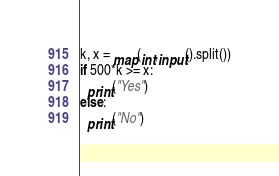Convert code to text. <code><loc_0><loc_0><loc_500><loc_500><_Python_>k, x = map(int,input().split())
if 500*k >= x:
  print("Yes")
else:
  print("No")</code> 